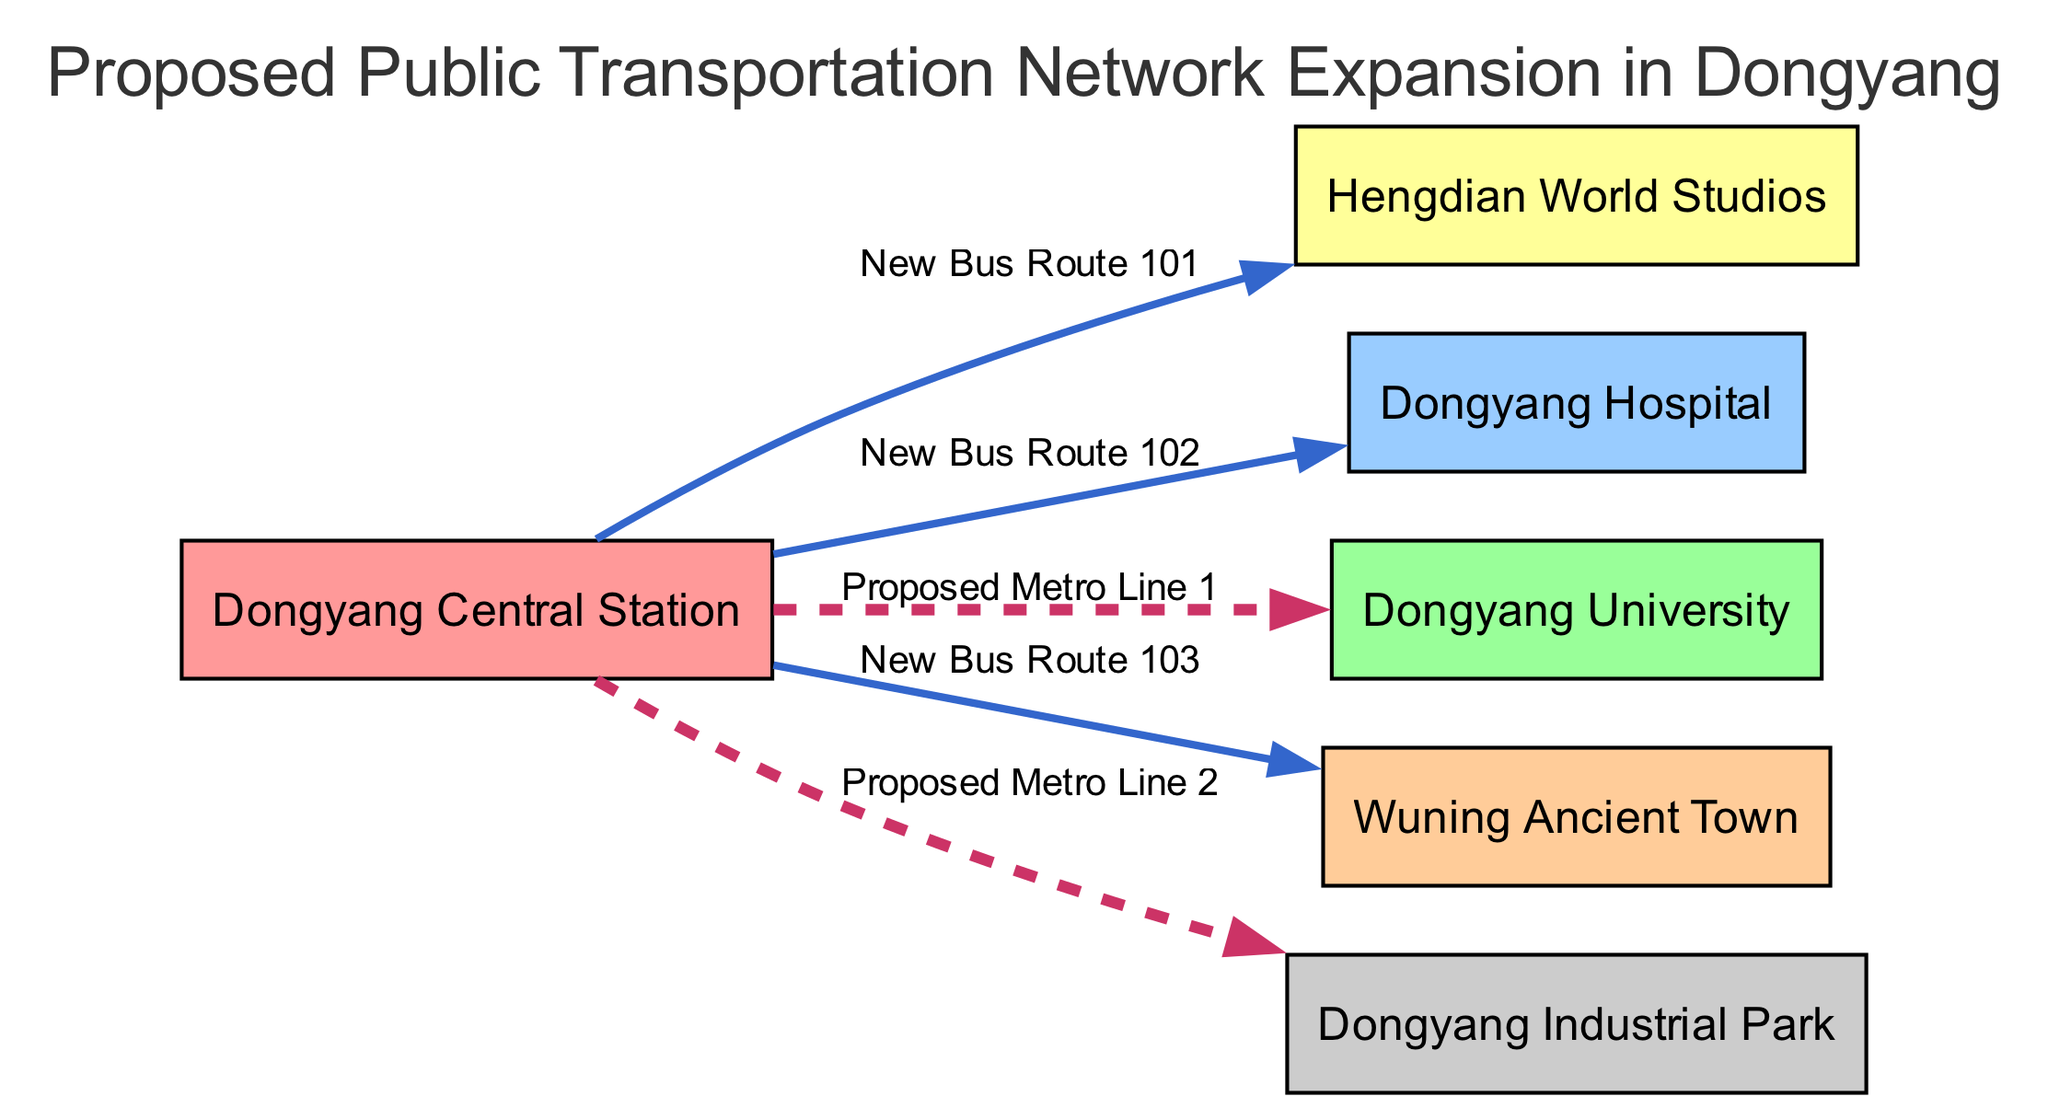What is the total number of nodes in the proposed transportation network? The diagram lists six entities labeled as nodes. By counting these entities - Dongyang Central Station, Hengdian World Studios, Dongyang Hospital, Dongyang University, Wuning Ancient Town, and Dongyang Industrial Park - we find that there are a total of six nodes.
Answer: 6 What is the label of the node connected to Dongyang Central Station by New Bus Route 101? The edge labeled New Bus Route 101 connects Dongyang Central Station (node 1) to Hengdian World Studios (node 2). By tracing this specific edge, the answer can be directly derived.
Answer: Hengdian World Studios How many new bus routes are proposed in this network? The diagram shows three edges labeled as New Bus Routes: 101, 102, and 103, indicating there are three dedicated bus routes. Counting these edges gives the total number of new bus routes proposed.
Answer: 3 Which node is proposed to be connected by Metro Line 1? The edge labeled Proposed Metro Line 1 connects Dongyang Central Station (node 1) to Dongyang University (node 4). Therefore, by analyzing this edge, we can ascertain the connection.
Answer: Dongyang University What is the relationship between Dongyang Central Station and Dongyang Industrial Park in the proposed network? The relationship is defined by the edge labeled Proposed Metro Line 2 that connects Dongyang Central Station (node 1) to Dongyang Industrial Park (node 6). This shows a direct connection between these two nodes.
Answer: Proposed Metro Line 2 Which location is connected to Dongyang Central Station by New Bus Route 103? The edge labeled New Bus Route 103 connects Dongyang Central Station (node 1) to Wuning Ancient Town (node 5). Referring to this edge allows us to find the connected location.
Answer: Wuning Ancient Town What type of edge connects Dongyang Central Station to Dongyang Hospital? The edge that connects Dongyang Central Station (node 1) to Dongyang Hospital (node 3) is labeled New Bus Route 102, which identifies it as a bus route rather than a metro line. Therefore, this classification can be easily inferred.
Answer: New Bus Route 102 Which node receives the most connections from Dongyang Central Station? By examining the edges stemming from Dongyang Central Station, we see it connects to Hengdian World Studios, Dongyang Hospital, Dongyang University, Wuning Ancient Town, and Dongyang Industrial Park. Since it connects to all five other nodes, this node has the most connections.
Answer: All other nodes 